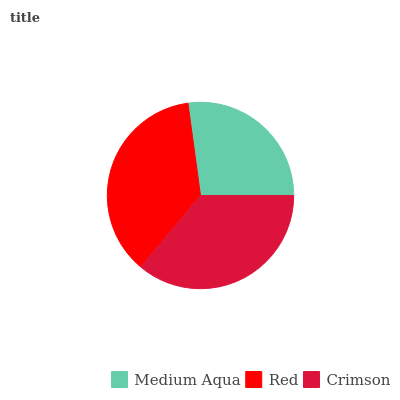Is Medium Aqua the minimum?
Answer yes or no. Yes. Is Red the maximum?
Answer yes or no. Yes. Is Crimson the minimum?
Answer yes or no. No. Is Crimson the maximum?
Answer yes or no. No. Is Red greater than Crimson?
Answer yes or no. Yes. Is Crimson less than Red?
Answer yes or no. Yes. Is Crimson greater than Red?
Answer yes or no. No. Is Red less than Crimson?
Answer yes or no. No. Is Crimson the high median?
Answer yes or no. Yes. Is Crimson the low median?
Answer yes or no. Yes. Is Red the high median?
Answer yes or no. No. Is Medium Aqua the low median?
Answer yes or no. No. 